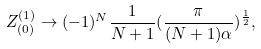<formula> <loc_0><loc_0><loc_500><loc_500>Z _ { ( 0 ) } ^ { ( 1 ) } \to ( - 1 ) ^ { N } \frac { 1 } { N + 1 } ( \frac { \pi } { ( N + 1 ) \alpha } ) ^ { \frac { 1 } { 2 } } ,</formula> 